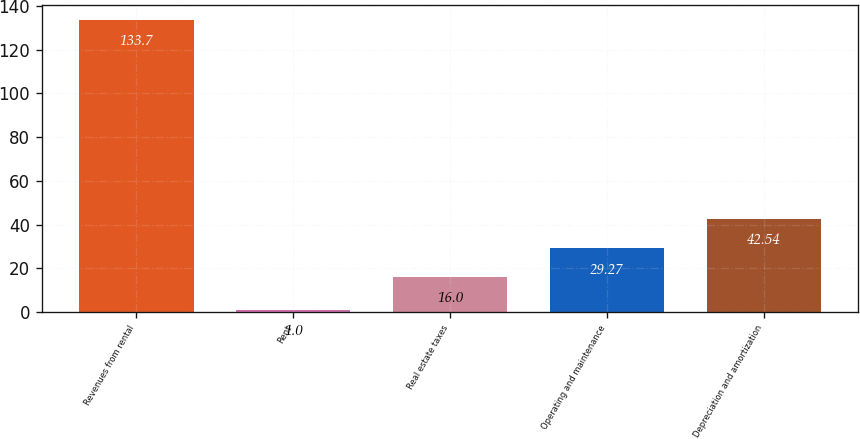<chart> <loc_0><loc_0><loc_500><loc_500><bar_chart><fcel>Revenues from rental<fcel>Rent<fcel>Real estate taxes<fcel>Operating and maintenance<fcel>Depreciation and amortization<nl><fcel>133.7<fcel>1<fcel>16<fcel>29.27<fcel>42.54<nl></chart> 